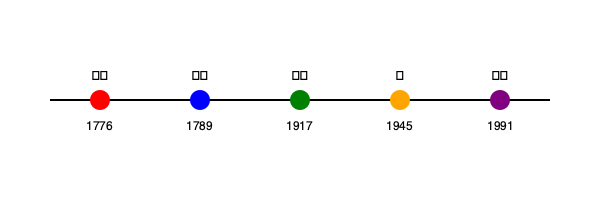Based on the timeline provided, which historical event represented by the blue circle had a significant impact on global politics and preceded the event symbolized by the green circle? To answer this question, let's analyze the timeline step-by-step:

1. The timeline shows five major historical events represented by colored circles and national flags or symbols.

2. The blue circle is dated 1789 and is associated with the French flag (🇫🇷).

3. The green circle is dated 1917 and is associated with the Russian flag (🇷🇺).

4. The event in 1789 precedes the event in 1917 chronologically.

5. The French flag in 1789 likely represents the French Revolution, which began in that year.

6. The French Revolution had a significant impact on global politics, spreading ideas of liberty, equality, and fraternity across Europe and beyond.

7. These ideas influenced many subsequent political movements and revolutions worldwide.

8. The 1917 event associated with Russia likely represents the Russian Revolution, which was partly inspired by ideas from the French Revolution.

Therefore, the French Revolution of 1789, represented by the blue circle, had a significant impact on global politics and preceded the event symbolized by the green circle (the Russian Revolution of 1917).
Answer: The French Revolution of 1789 